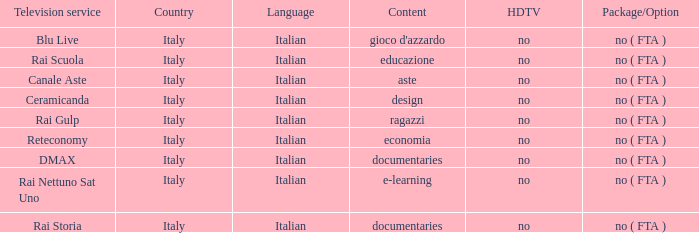What is the HDTV for the Rai Nettuno Sat Uno Television service? No. 